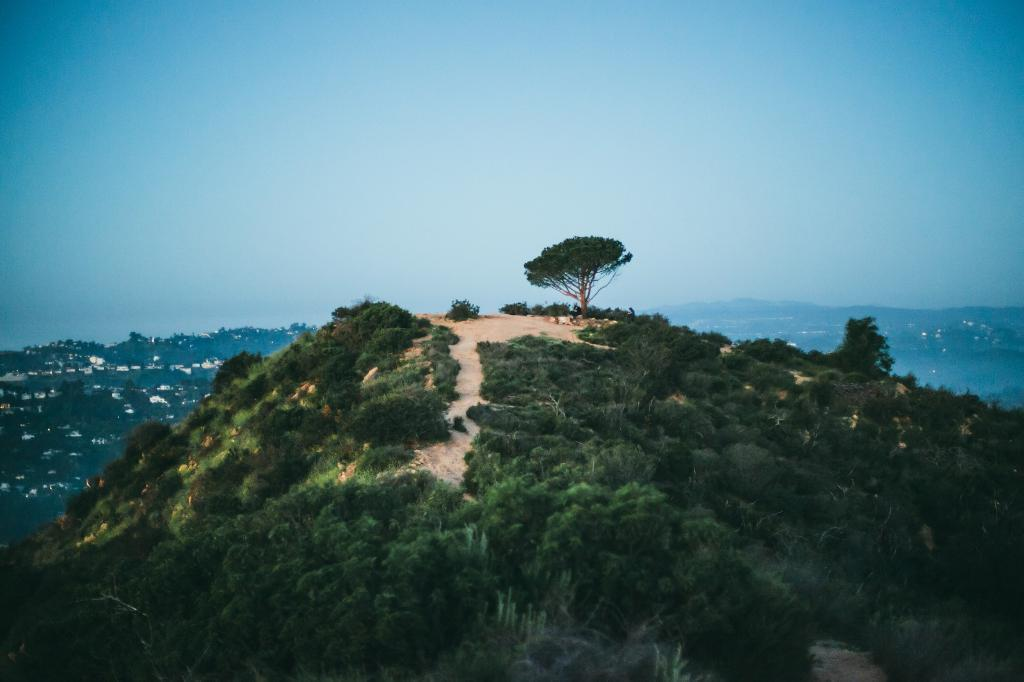What type of landform can be seen in the image? There is a hill in the image. What type of vegetation is present in the image? There are trees and plants in the image. What part of the natural environment is visible in the image? The ground is visible in the image. What is visible in the background of the image? The sky is visible in the background of the image. What type of elbow is visible in the image? There is no elbow present in the image. Can you tell me how many bags of popcorn are on the hill in the image? There is no popcorn present in the image; it features a hill, trees, plants, the ground, and the sky. 